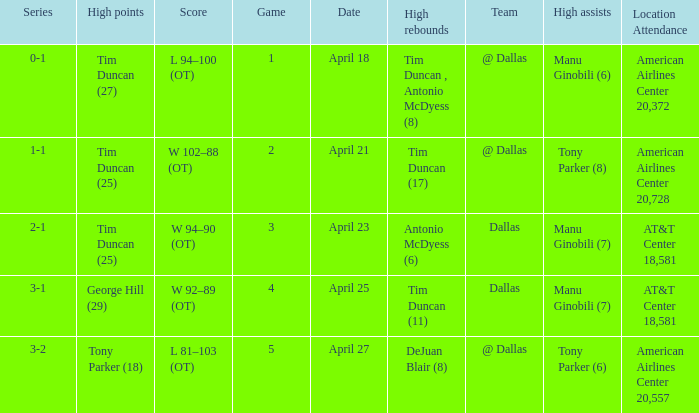When 1-1 is the series who is the team? @ Dallas. 